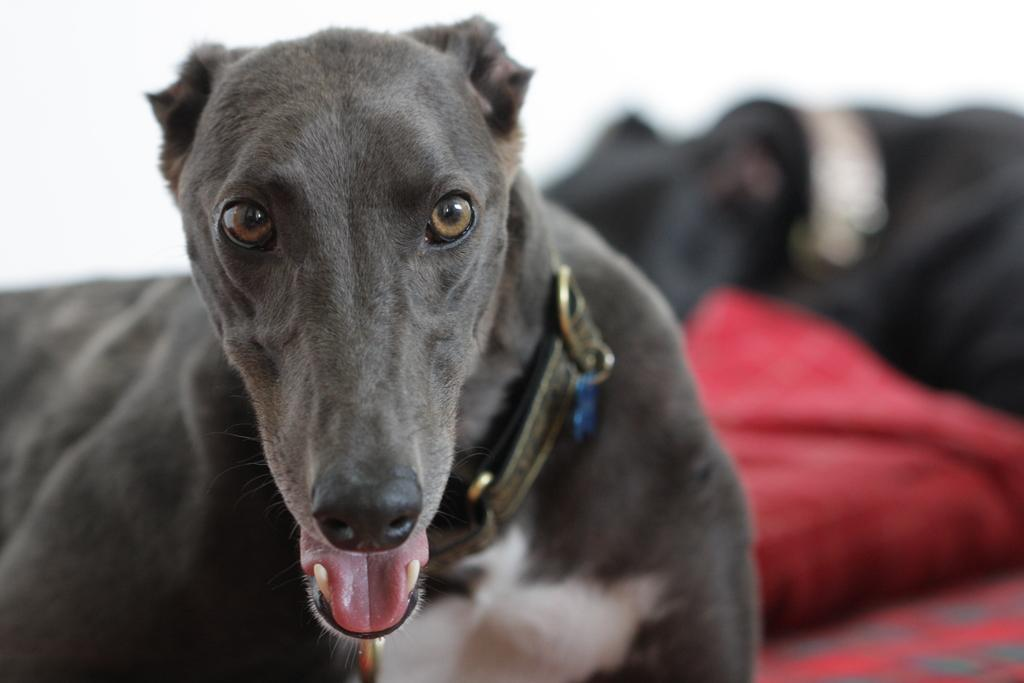What type of animal is in the image? There is a dog in the image. What is the dog wearing? The dog is wearing a belt. What color is the background of the image? The background of the image is white. What can be seen on the right side of the image? There is a blurred view on the right side of the image, and red, black, and white colors are present there. What type of leather is the cook using to prepare the meal in the image? There is no cook or meal preparation present in the image; it features a dog wearing a belt. Is the dog sleeping in the image? The image does not show the dog sleeping; it is wearing a belt and standing or sitting. 